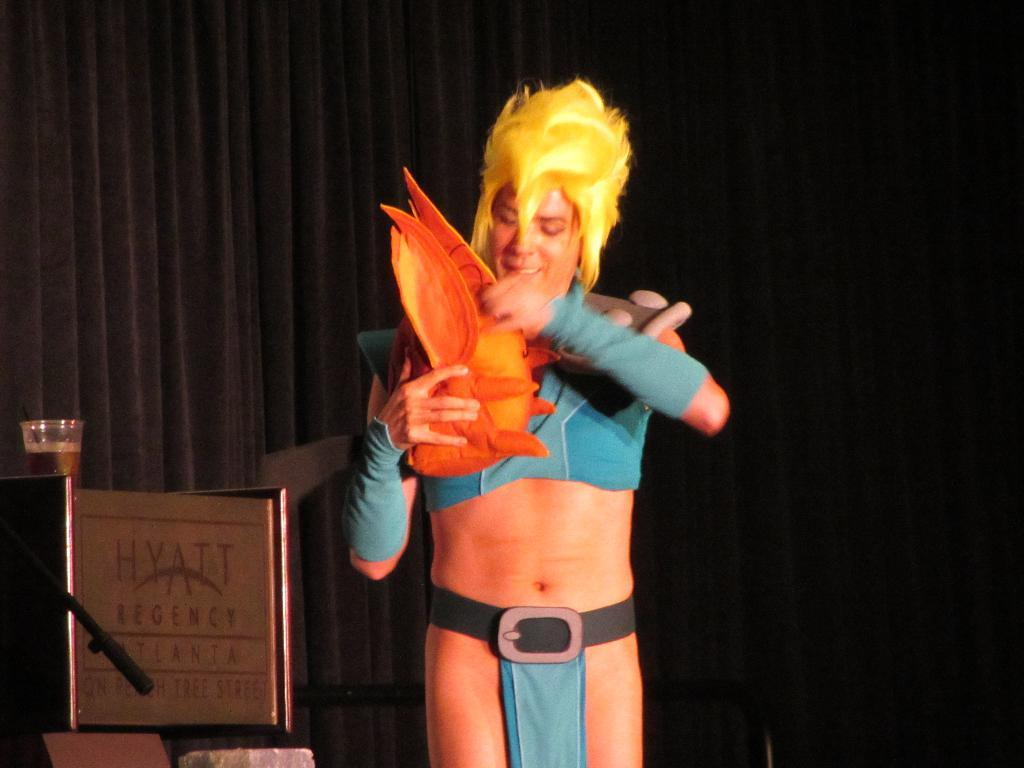What is the main subject in the center of the image? There is a person standing in the center of the image. What can be seen on the left side of the image? There is a glass on the left side of the image. Can you describe any other objects in the image? Yes, there are other objects in the image, but their specific details are not mentioned in the provided facts. What is visible in the background of the image? There is a curtain in the background of the image. What is the topic of the heated argument taking place in the image? There is no heated argument present in the image; it features a person standing in the center and a glass on the left side. What thrilling activity is the person engaging in within the image? The provided facts do not mention any thrilling activities; the person is simply standing in the center of the image. 